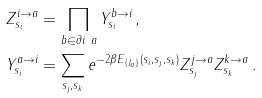Convert formula to latex. <formula><loc_0><loc_0><loc_500><loc_500>Z _ { s _ { i } } ^ { i \to a } & = \prod _ { b \in \partial i \ a } Y _ { s _ { i } } ^ { b \to i } \, , \\ Y _ { s _ { i } } ^ { a \to i } & = \sum _ { s _ { j } , s _ { k } } e ^ { - 2 \beta E _ { \{ J _ { a } \} } ( s _ { i } , s _ { j } , s _ { k } ) } Z _ { s _ { j } } ^ { j \to a } Z _ { s _ { k } } ^ { k \to a } \, .</formula> 